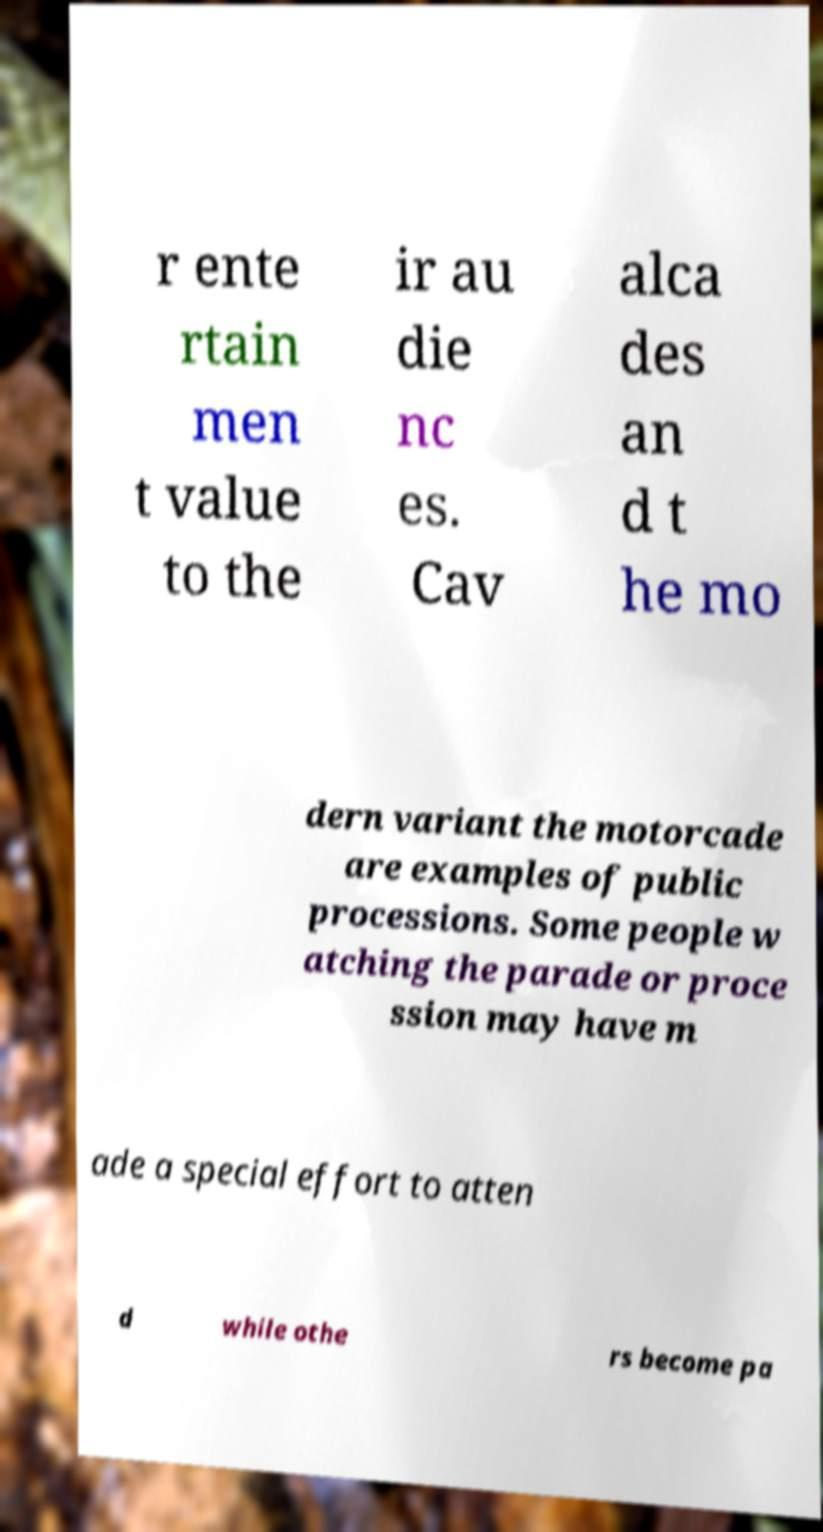For documentation purposes, I need the text within this image transcribed. Could you provide that? r ente rtain men t value to the ir au die nc es. Cav alca des an d t he mo dern variant the motorcade are examples of public processions. Some people w atching the parade or proce ssion may have m ade a special effort to atten d while othe rs become pa 